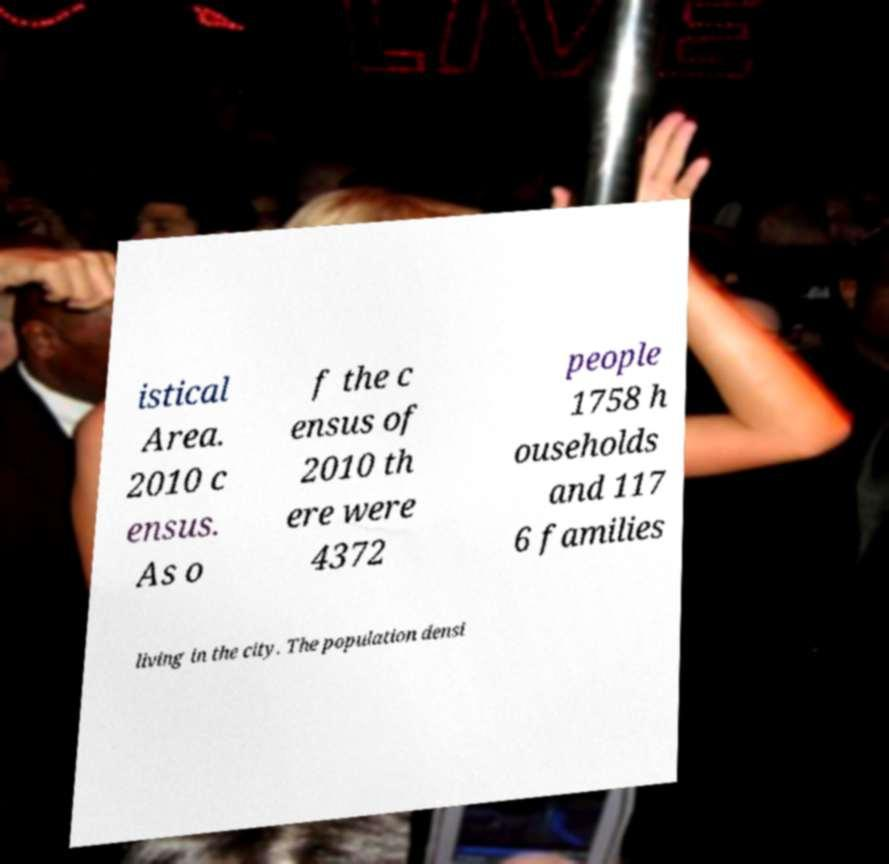I need the written content from this picture converted into text. Can you do that? istical Area. 2010 c ensus. As o f the c ensus of 2010 th ere were 4372 people 1758 h ouseholds and 117 6 families living in the city. The population densi 